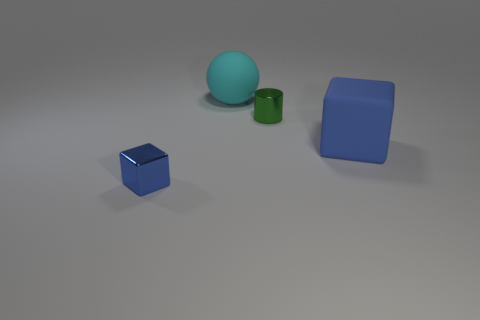Are there any other objects present on the outskirts of this setup that we cannot see? From the current perspective provided by the image, no additional objects are visible outside the central composition of the blue cube, green cylinder, larger blue cube, and cyan sphere. However, without seeing beyond the frame, it's impossible to determine with certainty if there are any other items outside the view. 